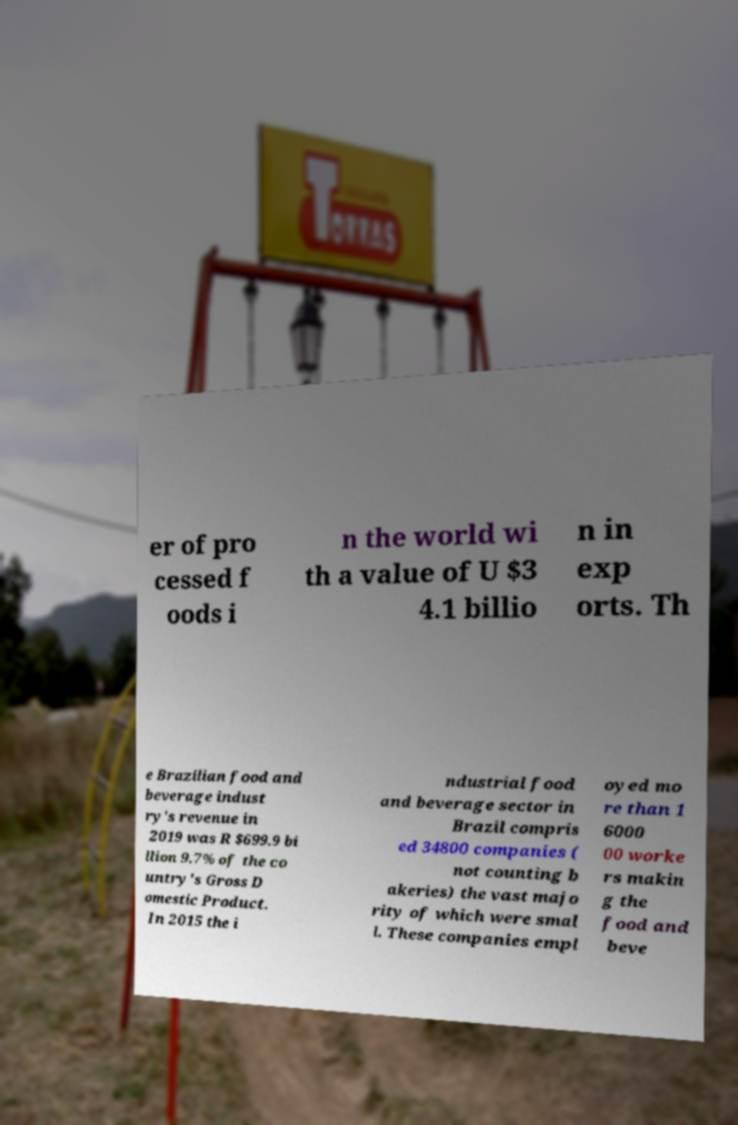Can you read and provide the text displayed in the image?This photo seems to have some interesting text. Can you extract and type it out for me? er of pro cessed f oods i n the world wi th a value of U $3 4.1 billio n in exp orts. Th e Brazilian food and beverage indust ry's revenue in 2019 was R $699.9 bi llion 9.7% of the co untry's Gross D omestic Product. In 2015 the i ndustrial food and beverage sector in Brazil compris ed 34800 companies ( not counting b akeries) the vast majo rity of which were smal l. These companies empl oyed mo re than 1 6000 00 worke rs makin g the food and beve 